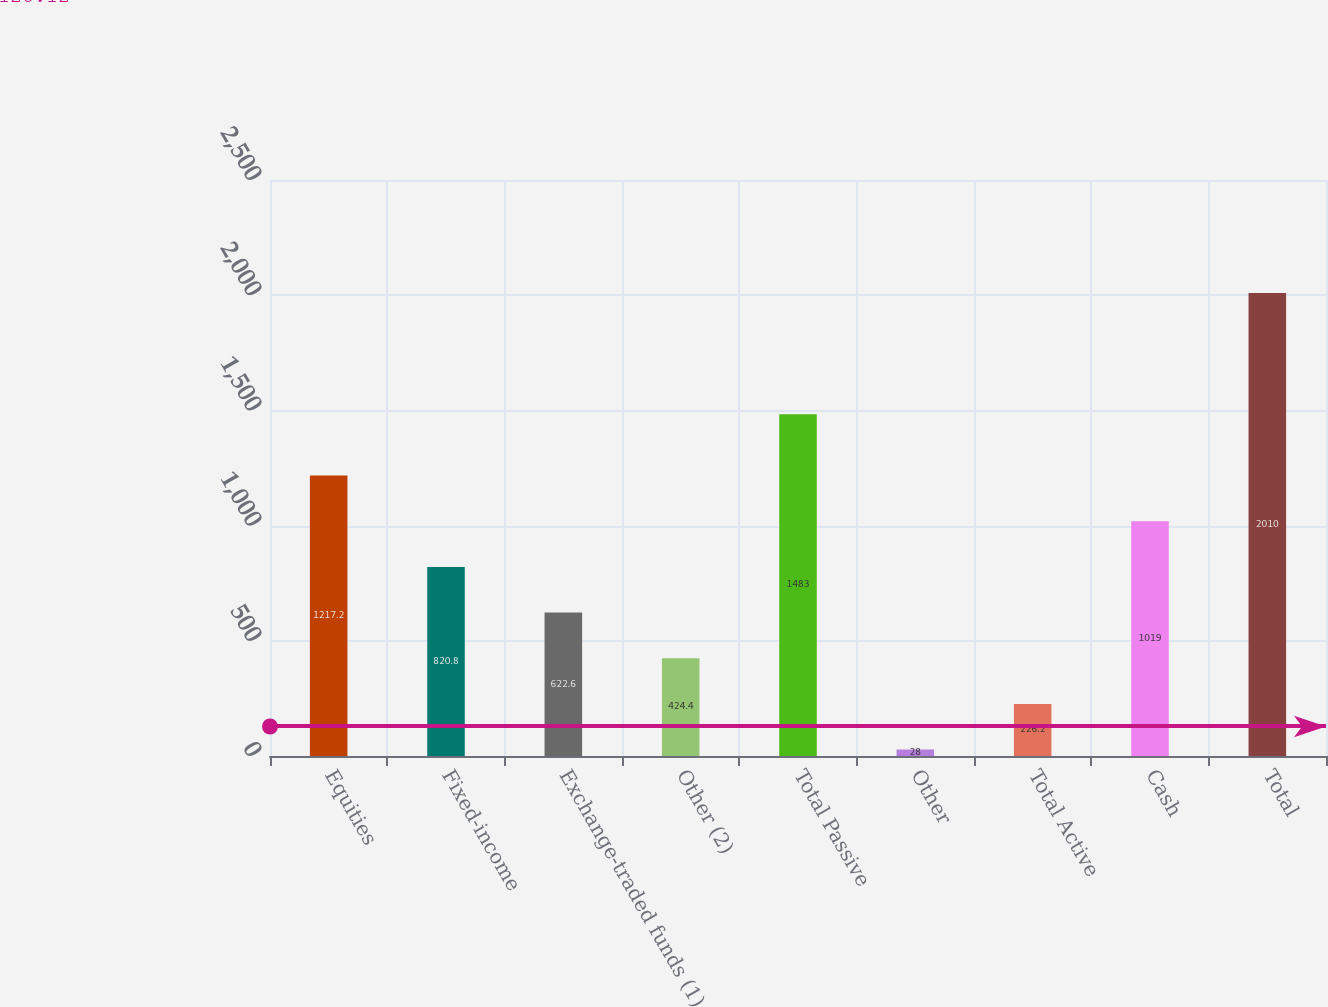Convert chart to OTSL. <chart><loc_0><loc_0><loc_500><loc_500><bar_chart><fcel>Equities<fcel>Fixed-income<fcel>Exchange-traded funds (1)<fcel>Other (2)<fcel>Total Passive<fcel>Other<fcel>Total Active<fcel>Cash<fcel>Total<nl><fcel>1217.2<fcel>820.8<fcel>622.6<fcel>424.4<fcel>1483<fcel>28<fcel>226.2<fcel>1019<fcel>2010<nl></chart> 